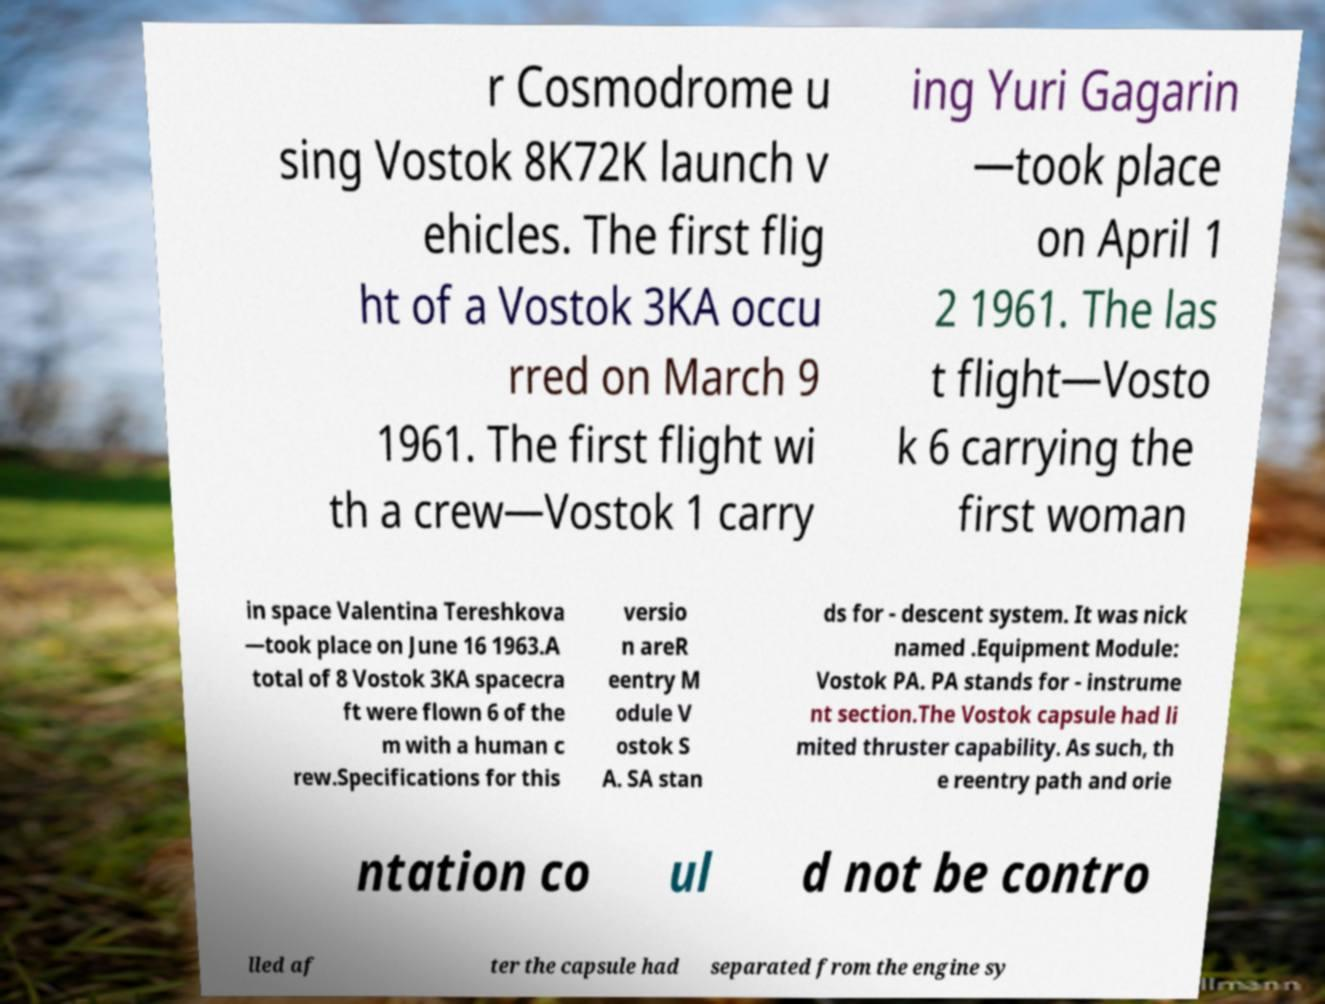There's text embedded in this image that I need extracted. Can you transcribe it verbatim? r Cosmodrome u sing Vostok 8K72K launch v ehicles. The first flig ht of a Vostok 3KA occu rred on March 9 1961. The first flight wi th a crew—Vostok 1 carry ing Yuri Gagarin —took place on April 1 2 1961. The las t flight—Vosto k 6 carrying the first woman in space Valentina Tereshkova —took place on June 16 1963.A total of 8 Vostok 3KA spacecra ft were flown 6 of the m with a human c rew.Specifications for this versio n areR eentry M odule V ostok S A. SA stan ds for - descent system. It was nick named .Equipment Module: Vostok PA. PA stands for - instrume nt section.The Vostok capsule had li mited thruster capability. As such, th e reentry path and orie ntation co ul d not be contro lled af ter the capsule had separated from the engine sy 